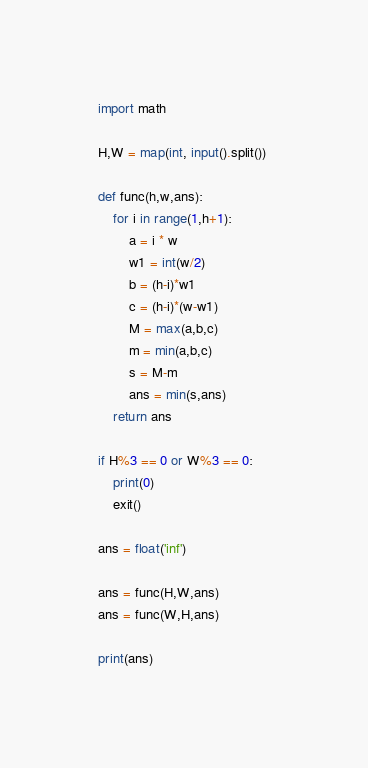Convert code to text. <code><loc_0><loc_0><loc_500><loc_500><_Python_>import math

H,W = map(int, input().split()) 

def func(h,w,ans):
    for i in range(1,h+1):
        a = i * w 
        w1 = int(w/2)
        b = (h-i)*w1
        c = (h-i)*(w-w1)
        M = max(a,b,c)
        m = min(a,b,c)
        s = M-m
        ans = min(s,ans) 
    return ans

if H%3 == 0 or W%3 == 0:
    print(0)
    exit()

ans = float('inf')

ans = func(H,W,ans)
ans = func(W,H,ans)

print(ans)</code> 